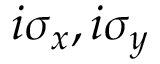Convert formula to latex. <formula><loc_0><loc_0><loc_500><loc_500>i \sigma _ { x } , i \sigma _ { y }</formula> 